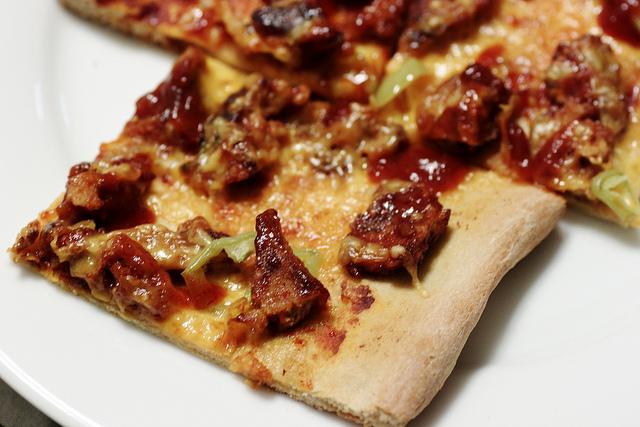Is the pizza on a plate?
Be succinct. Yes. What shape are the pizza slices cut into?
Keep it brief. Square. Is there meat on the pizza?
Keep it brief. Yes. 